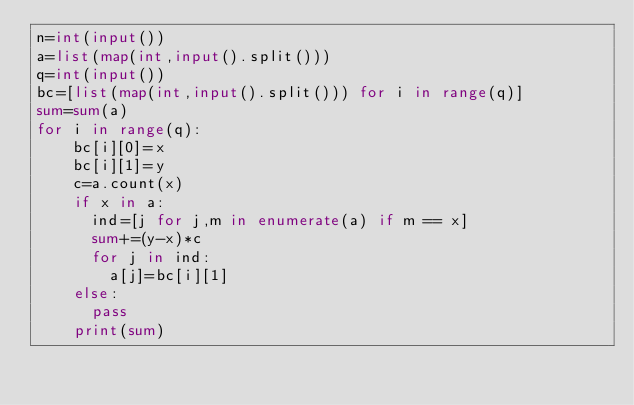<code> <loc_0><loc_0><loc_500><loc_500><_Python_>n=int(input())
a=list(map(int,input().split()))
q=int(input())
bc=[list(map(int,input().split())) for i in range(q)]
sum=sum(a)
for i in range(q):
    bc[i][0]=x
    bc[i][1]=y
    c=a.count(x)
    if x in a:
      ind=[j for j,m in enumerate(a) if m == x]
      sum+=(y-x)*c
      for j in ind:
        a[j]=bc[i][1]
    else:
      pass
    print(sum)</code> 